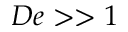Convert formula to latex. <formula><loc_0><loc_0><loc_500><loc_500>D e > > 1</formula> 